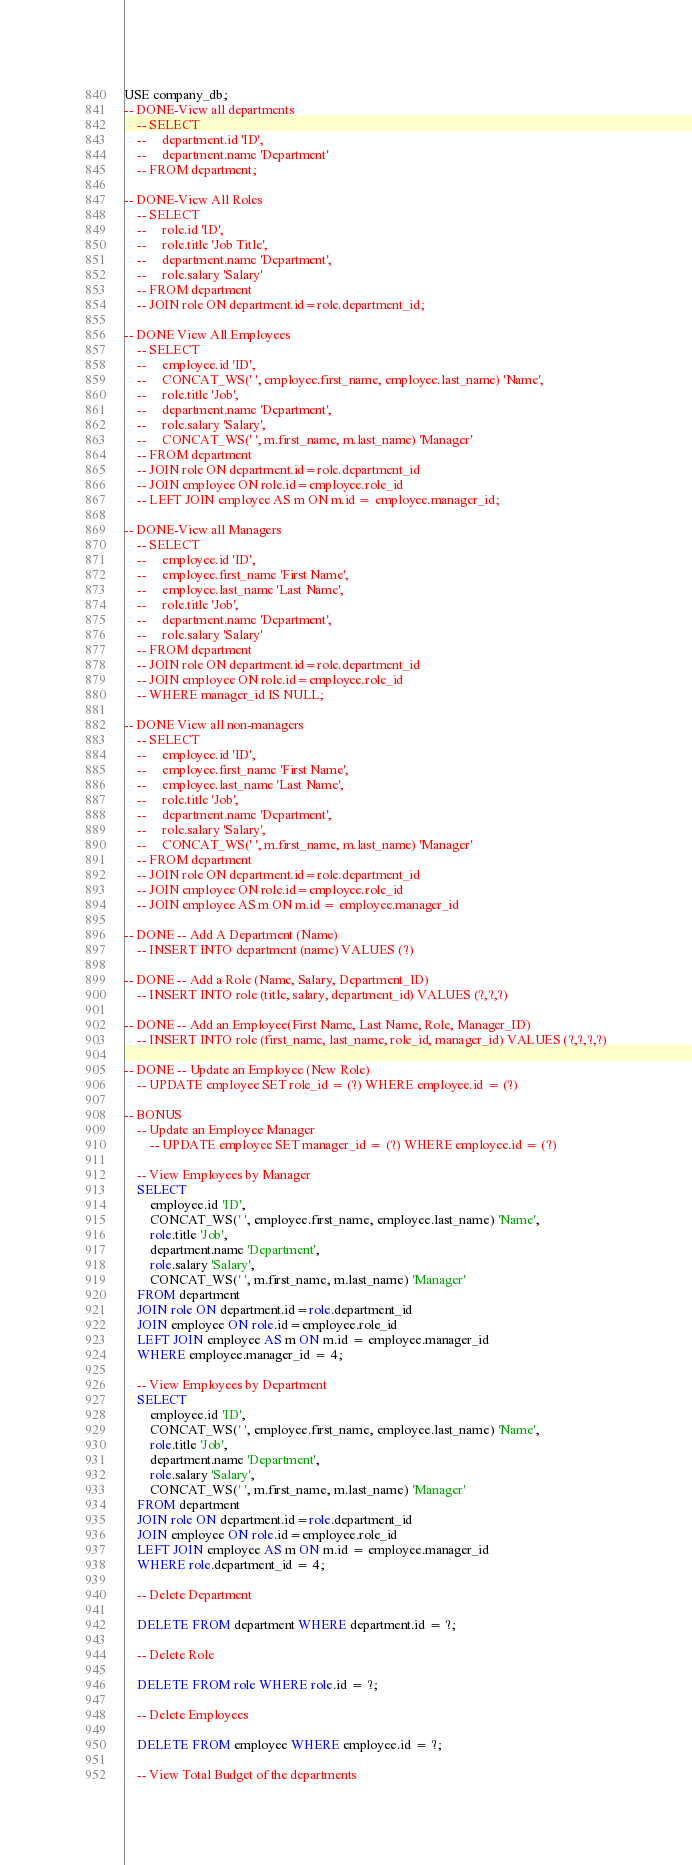<code> <loc_0><loc_0><loc_500><loc_500><_SQL_>USE company_db;
-- DONE-View all departments 
    -- SELECT
    --     department.id 'ID',
    --     department.name 'Department'
    -- FROM department;

-- DONE-View All Roles 
    -- SELECT 
    --     role.id 'ID',
    --     role.title 'Job Title',
    --     department.name 'Department',
    --     role.salary 'Salary'
    -- FROM department
    -- JOIN role ON department.id=role.department_id;

-- DONE View All Employees
    -- SELECT 
    --     employee.id 'ID', 
    --     CONCAT_WS(' ', employee.first_name, employee.last_name) 'Name', 
    --     role.title 'Job',
    --     department.name 'Department',
    --     role.salary 'Salary',
    --     CONCAT_WS(' ', m.first_name, m.last_name) 'Manager'
    -- FROM department 
    -- JOIN role ON department.id=role.department_id
    -- JOIN employee ON role.id=employee.role_id
    -- LEFT JOIN employee AS m ON m.id = employee.manager_id;

-- DONE-View all Managers 
    -- SELECT 
    --     employee.id 'ID', 
    --     employee.first_name 'First Name', 
    --     employee.last_name 'Last Name', 
    --     role.title 'Job',
    --     department.name 'Department',
    --     role.salary 'Salary'
    -- FROM department 
    -- JOIN role ON department.id=role.department_id
    -- JOIN employee ON role.id=employee.role_id
    -- WHERE manager_id IS NULL;
        
-- DONE View all non-managers
    -- SELECT 
    --     employee.id 'ID', 
    --     employee.first_name 'First Name', 
    --     employee.last_name 'Last Name', 
    --     role.title 'Job',
    --     department.name 'Department',
    --     role.salary 'Salary',
    --     CONCAT_WS(' ', m.first_name, m.last_name) 'Manager'
    -- FROM department 
    -- JOIN role ON department.id=role.department_id
    -- JOIN employee ON role.id=employee.role_id
    -- JOIN employee AS m ON m.id = employee.manager_id

-- DONE -- Add A Department (Name)
    -- INSERT INTO department (name) VALUES (?)

-- DONE -- Add a Role (Name, Salary, Department_ID)
    -- INSERT INTO role (title, salary, department_id) VALUES (?,?,?)

-- DONE -- Add an Employee(First Name, Last Name, Role, Manager_ID)
    -- INSERT INTO role (first_name, last_name, role_id, manager_id) VALUES (?,?,?,?)

-- DONE -- Update an Employee (New Role)
    -- UPDATE employee SET role_id = (?) WHERE employee.id = (?)

-- BONUS
    -- Update an Employee Manager
        -- UPDATE employee SET manager_id = (?) WHERE employee.id = (?)

    -- View Employees by Manager
    SELECT 
        employee.id 'ID', 
        CONCAT_WS(' ', employee.first_name, employee.last_name) 'Name', 
        role.title 'Job',
        department.name 'Department',
        role.salary 'Salary',
        CONCAT_WS(' ', m.first_name, m.last_name) 'Manager'
    FROM department 
    JOIN role ON department.id=role.department_id
    JOIN employee ON role.id=employee.role_id
    LEFT JOIN employee AS m ON m.id = employee.manager_id
    WHERE employee.manager_id = 4;

    -- View Employees by Department
    SELECT 
        employee.id 'ID', 
        CONCAT_WS(' ', employee.first_name, employee.last_name) 'Name', 
        role.title 'Job',
        department.name 'Department',
        role.salary 'Salary',
        CONCAT_WS(' ', m.first_name, m.last_name) 'Manager'
    FROM department 
    JOIN role ON department.id=role.department_id
    JOIN employee ON role.id=employee.role_id
    LEFT JOIN employee AS m ON m.id = employee.manager_id
    WHERE role.department_id = 4;

    -- Delete Department 
    
    DELETE FROM department WHERE department.id = ?;
    
    -- Delete Role 

    DELETE FROM role WHERE role.id = ?;
    
    -- Delete Employees

    DELETE FROM employee WHERE employee.id = ?;

    -- View Total Budget of the departments
</code> 